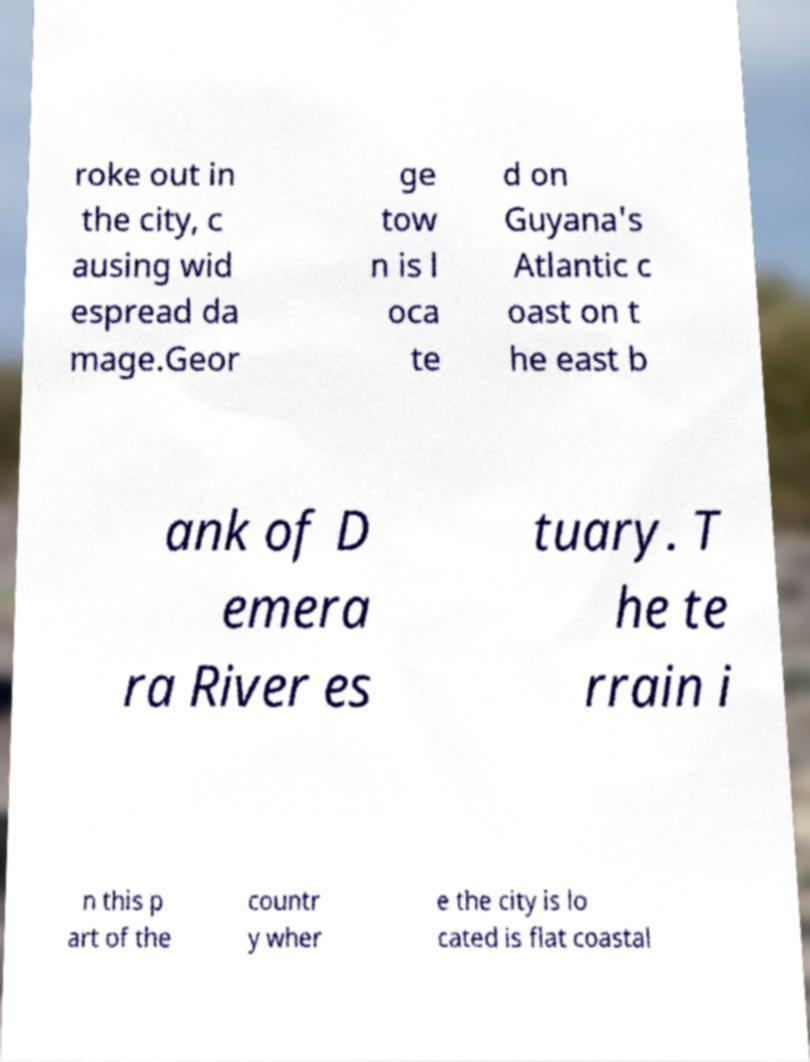Please read and relay the text visible in this image. What does it say? roke out in the city, c ausing wid espread da mage.Geor ge tow n is l oca te d on Guyana's Atlantic c oast on t he east b ank of D emera ra River es tuary. T he te rrain i n this p art of the countr y wher e the city is lo cated is flat coastal 